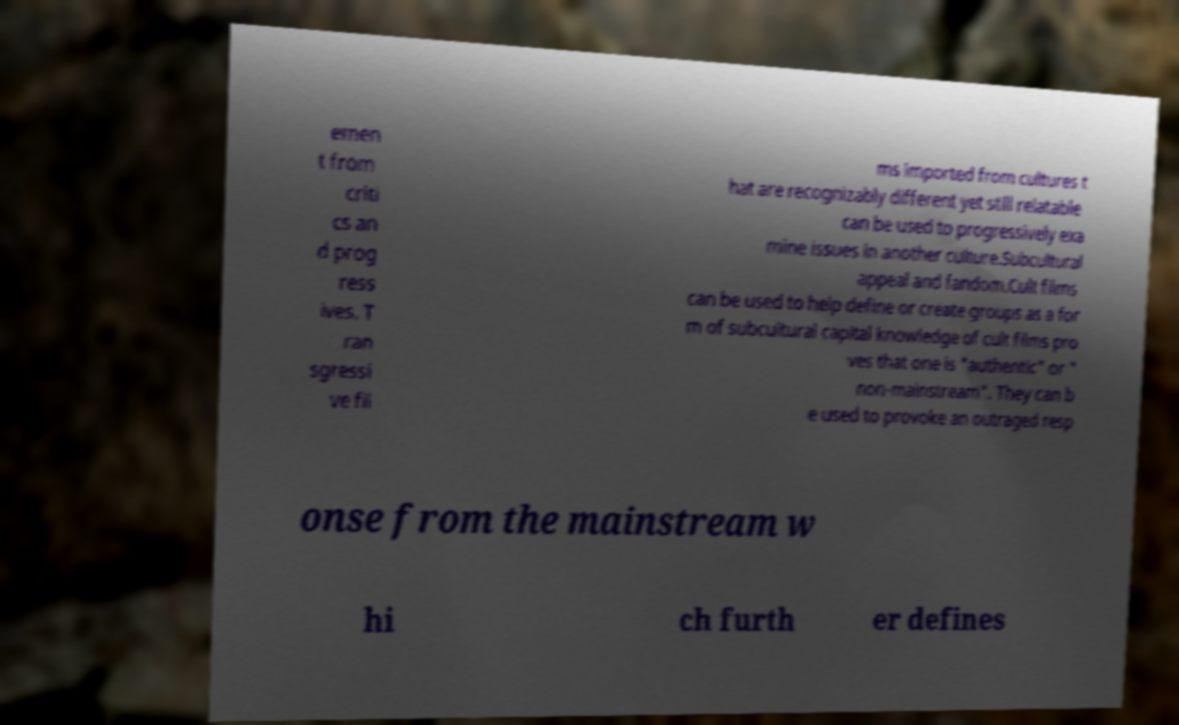Could you extract and type out the text from this image? emen t from criti cs an d prog ress ives. T ran sgressi ve fil ms imported from cultures t hat are recognizably different yet still relatable can be used to progressively exa mine issues in another culture.Subcultural appeal and fandom.Cult films can be used to help define or create groups as a for m of subcultural capital knowledge of cult films pro ves that one is "authentic" or " non-mainstream". They can b e used to provoke an outraged resp onse from the mainstream w hi ch furth er defines 